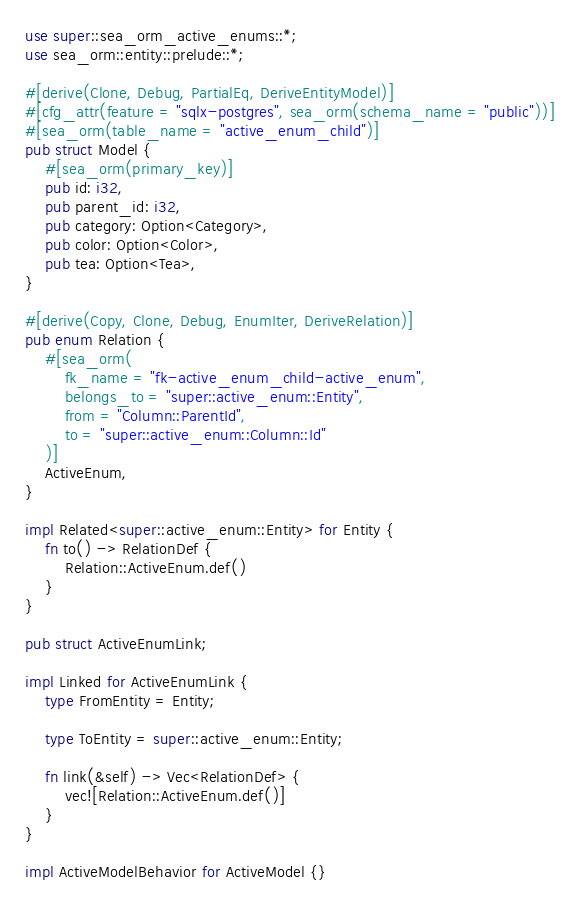<code> <loc_0><loc_0><loc_500><loc_500><_Rust_>use super::sea_orm_active_enums::*;
use sea_orm::entity::prelude::*;

#[derive(Clone, Debug, PartialEq, DeriveEntityModel)]
#[cfg_attr(feature = "sqlx-postgres", sea_orm(schema_name = "public"))]
#[sea_orm(table_name = "active_enum_child")]
pub struct Model {
    #[sea_orm(primary_key)]
    pub id: i32,
    pub parent_id: i32,
    pub category: Option<Category>,
    pub color: Option<Color>,
    pub tea: Option<Tea>,
}

#[derive(Copy, Clone, Debug, EnumIter, DeriveRelation)]
pub enum Relation {
    #[sea_orm(
        fk_name = "fk-active_enum_child-active_enum",
        belongs_to = "super::active_enum::Entity",
        from = "Column::ParentId",
        to = "super::active_enum::Column::Id"
    )]
    ActiveEnum,
}

impl Related<super::active_enum::Entity> for Entity {
    fn to() -> RelationDef {
        Relation::ActiveEnum.def()
    }
}

pub struct ActiveEnumLink;

impl Linked for ActiveEnumLink {
    type FromEntity = Entity;

    type ToEntity = super::active_enum::Entity;

    fn link(&self) -> Vec<RelationDef> {
        vec![Relation::ActiveEnum.def()]
    }
}

impl ActiveModelBehavior for ActiveModel {}
</code> 